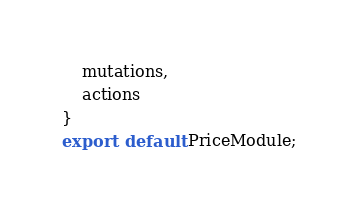Convert code to text. <code><loc_0><loc_0><loc_500><loc_500><_JavaScript_>    mutations,
    actions
}
export  default PriceModule;
</code> 